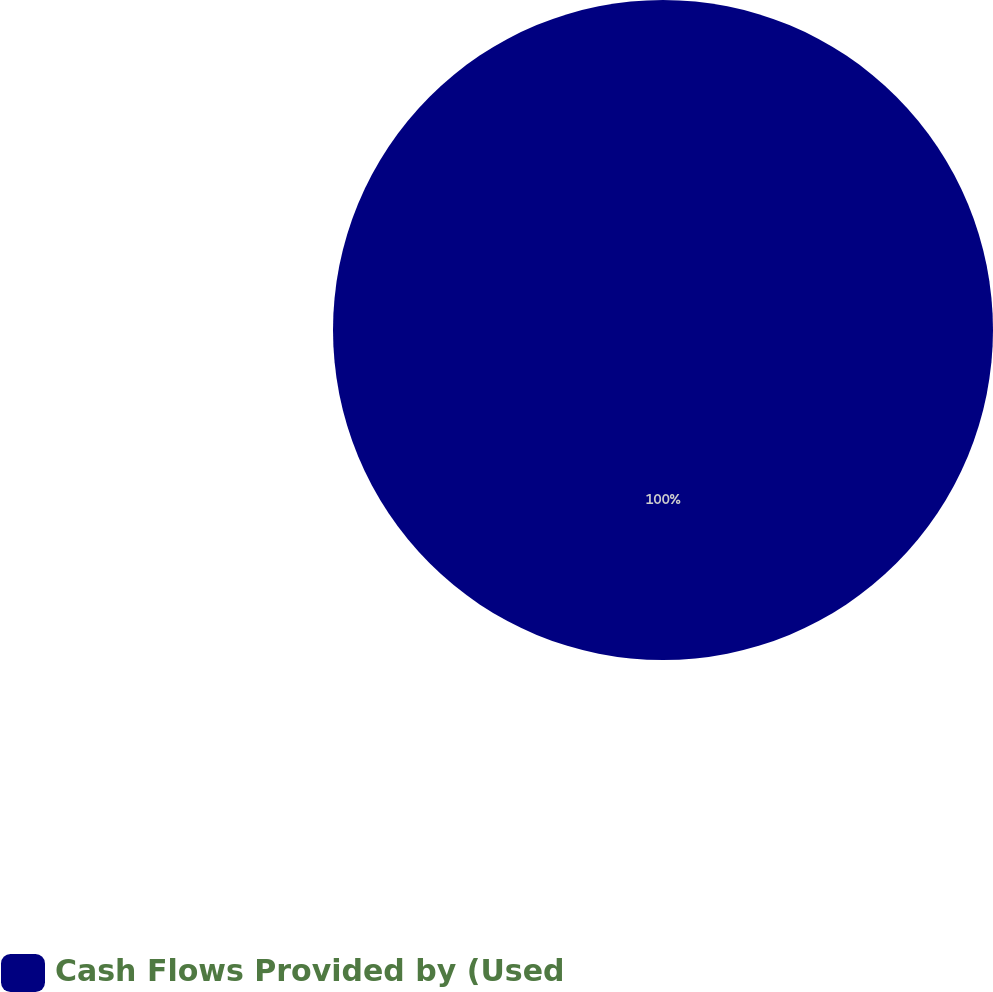Convert chart. <chart><loc_0><loc_0><loc_500><loc_500><pie_chart><fcel>Cash Flows Provided by (Used<nl><fcel>100.0%<nl></chart> 